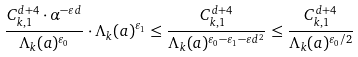Convert formula to latex. <formula><loc_0><loc_0><loc_500><loc_500>\frac { C _ { k , 1 } ^ { d + 4 } \cdot \alpha ^ { - \varepsilon d } } { \Lambda _ { k } ( a ) ^ { \varepsilon _ { 0 } } } \cdot \Lambda _ { k } ( a ) ^ { \varepsilon _ { 1 } } \leq \frac { C _ { k , 1 } ^ { d + 4 } } { \Lambda _ { k } ( a ) ^ { \varepsilon _ { 0 } - \varepsilon _ { 1 } - \varepsilon d ^ { 2 } } } \leq \frac { C _ { k , 1 } ^ { d + 4 } } { \Lambda _ { k } ( a ) ^ { \varepsilon _ { 0 } / 2 } }</formula> 